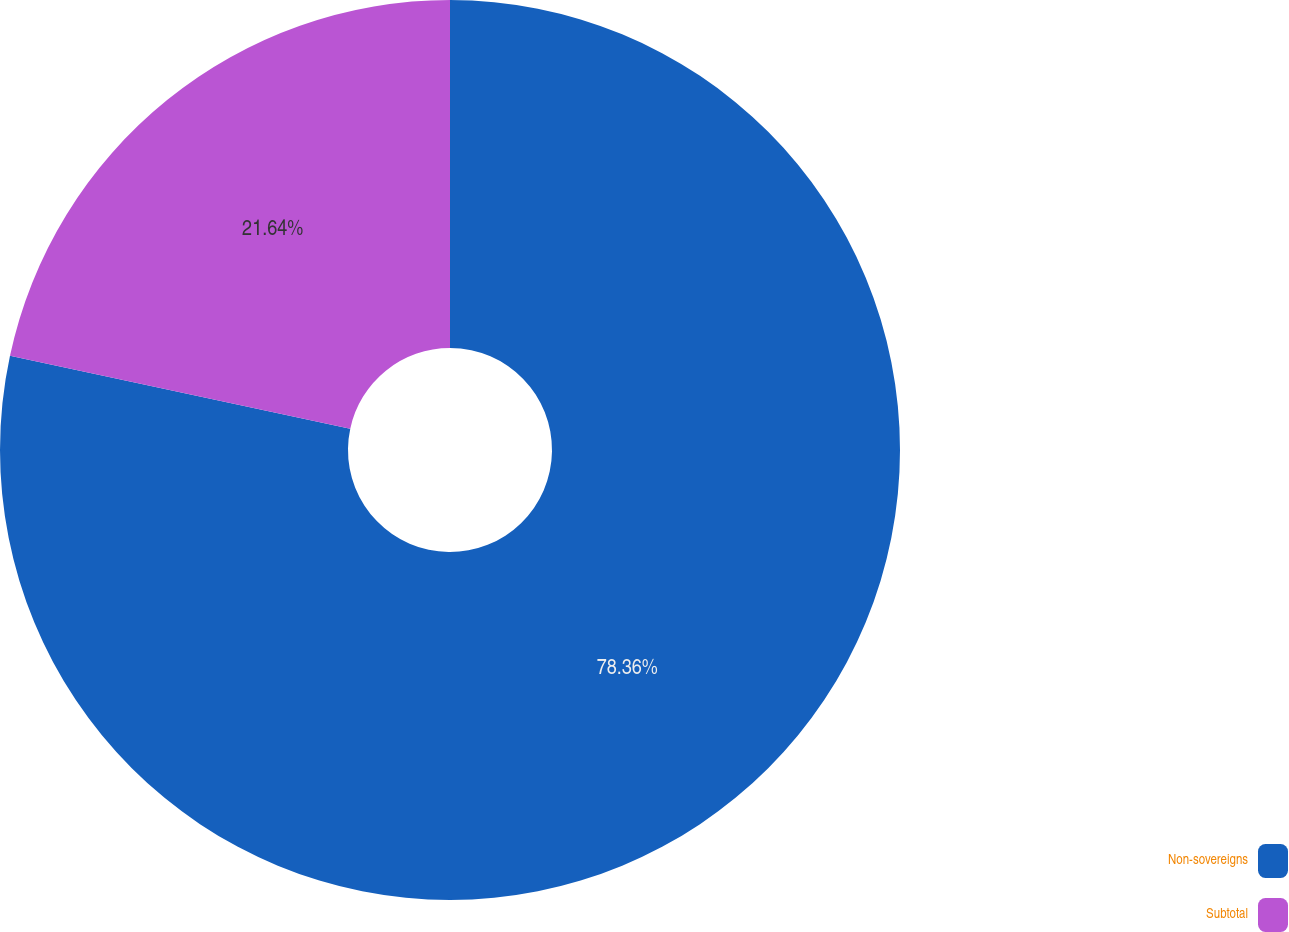<chart> <loc_0><loc_0><loc_500><loc_500><pie_chart><fcel>Non-sovereigns<fcel>Subtotal<nl><fcel>78.36%<fcel>21.64%<nl></chart> 